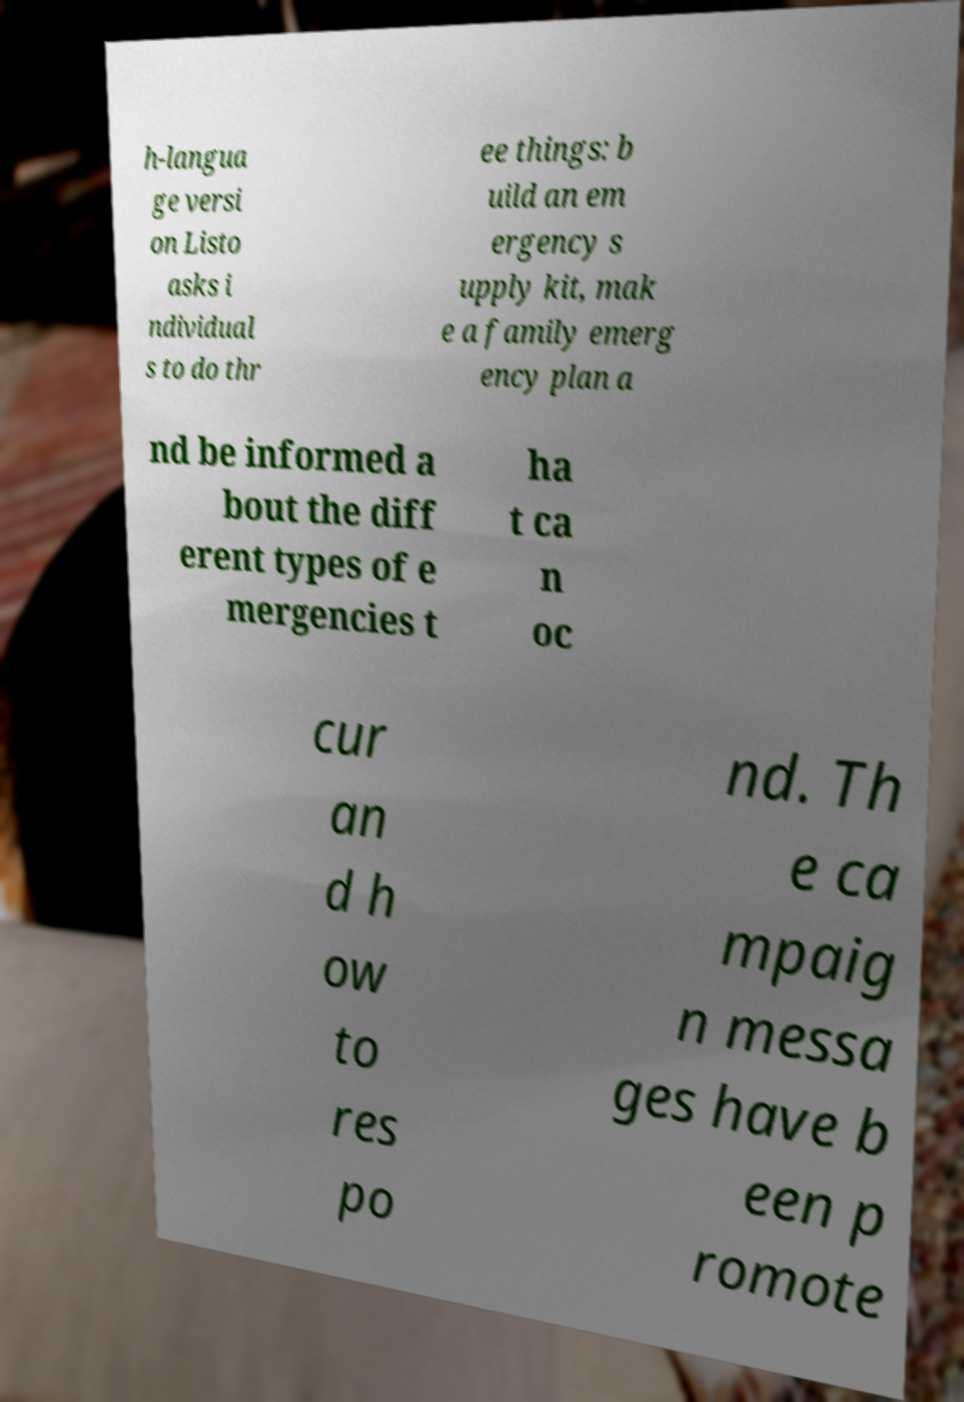What messages or text are displayed in this image? I need them in a readable, typed format. h-langua ge versi on Listo asks i ndividual s to do thr ee things: b uild an em ergency s upply kit, mak e a family emerg ency plan a nd be informed a bout the diff erent types of e mergencies t ha t ca n oc cur an d h ow to res po nd. Th e ca mpaig n messa ges have b een p romote 